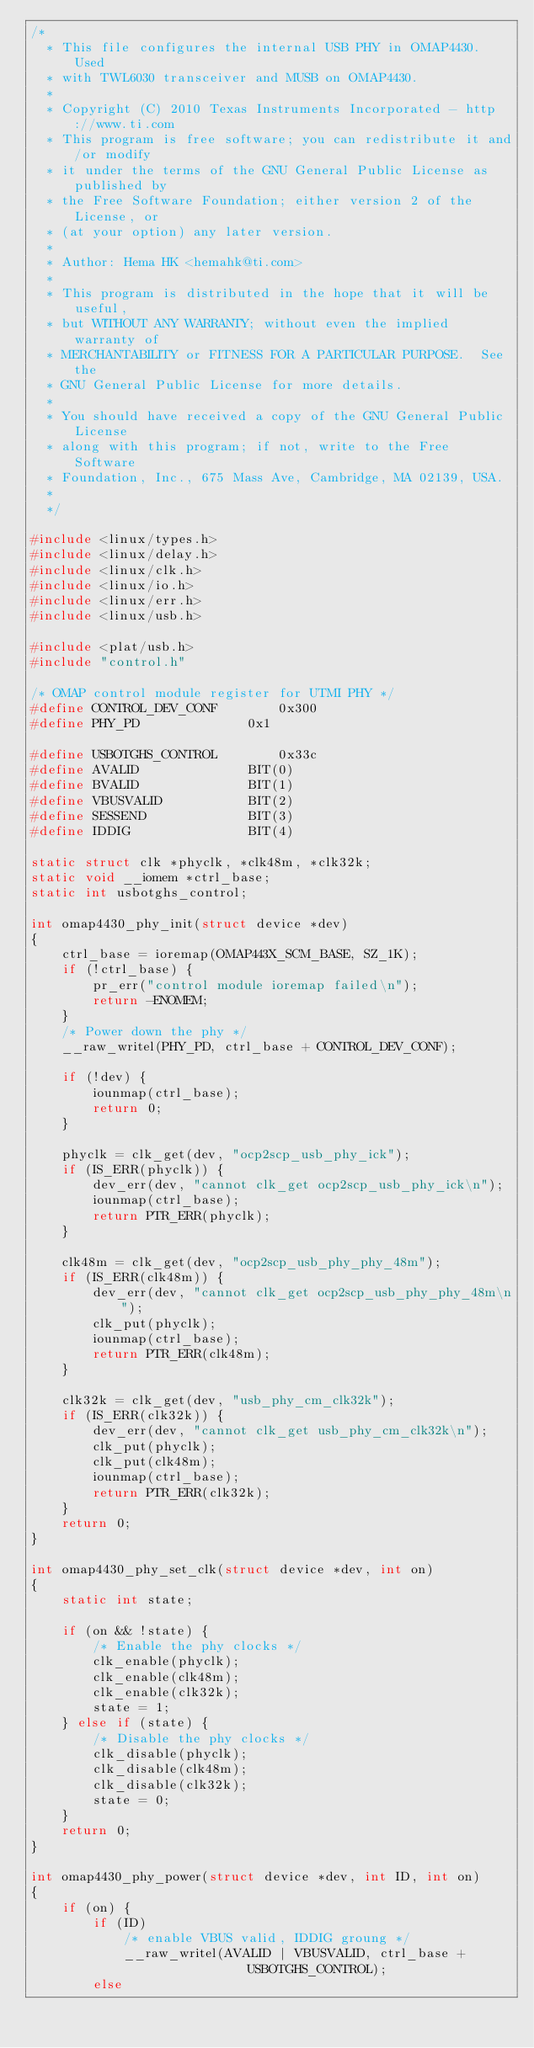<code> <loc_0><loc_0><loc_500><loc_500><_C_>/*
  * This file configures the internal USB PHY in OMAP4430. Used
  * with TWL6030 transceiver and MUSB on OMAP4430.
  *
  * Copyright (C) 2010 Texas Instruments Incorporated - http://www.ti.com
  * This program is free software; you can redistribute it and/or modify
  * it under the terms of the GNU General Public License as published by
  * the Free Software Foundation; either version 2 of the License, or
  * (at your option) any later version.
  *
  * Author: Hema HK <hemahk@ti.com>
  *
  * This program is distributed in the hope that it will be useful,
  * but WITHOUT ANY WARRANTY; without even the implied warranty of
  * MERCHANTABILITY or FITNESS FOR A PARTICULAR PURPOSE.  See the
  * GNU General Public License for more details.
  *
  * You should have received a copy of the GNU General Public License
  * along with this program; if not, write to the Free Software
  * Foundation, Inc., 675 Mass Ave, Cambridge, MA 02139, USA.
  *
  */

#include <linux/types.h>
#include <linux/delay.h>
#include <linux/clk.h>
#include <linux/io.h>
#include <linux/err.h>
#include <linux/usb.h>

#include <plat/usb.h>
#include "control.h"

/* OMAP control module register for UTMI PHY */
#define CONTROL_DEV_CONF		0x300
#define PHY_PD				0x1

#define USBOTGHS_CONTROL		0x33c
#define	AVALID				BIT(0)
#define	BVALID				BIT(1)
#define	VBUSVALID			BIT(2)
#define	SESSEND				BIT(3)
#define	IDDIG				BIT(4)

static struct clk *phyclk, *clk48m, *clk32k;
static void __iomem *ctrl_base;
static int usbotghs_control;

int omap4430_phy_init(struct device *dev)
{
	ctrl_base = ioremap(OMAP443X_SCM_BASE, SZ_1K);
	if (!ctrl_base) {
		pr_err("control module ioremap failed\n");
		return -ENOMEM;
	}
	/* Power down the phy */
	__raw_writel(PHY_PD, ctrl_base + CONTROL_DEV_CONF);

	if (!dev) {
		iounmap(ctrl_base);
		return 0;
	}

	phyclk = clk_get(dev, "ocp2scp_usb_phy_ick");
	if (IS_ERR(phyclk)) {
		dev_err(dev, "cannot clk_get ocp2scp_usb_phy_ick\n");
		iounmap(ctrl_base);
		return PTR_ERR(phyclk);
	}

	clk48m = clk_get(dev, "ocp2scp_usb_phy_phy_48m");
	if (IS_ERR(clk48m)) {
		dev_err(dev, "cannot clk_get ocp2scp_usb_phy_phy_48m\n");
		clk_put(phyclk);
		iounmap(ctrl_base);
		return PTR_ERR(clk48m);
	}

	clk32k = clk_get(dev, "usb_phy_cm_clk32k");
	if (IS_ERR(clk32k)) {
		dev_err(dev, "cannot clk_get usb_phy_cm_clk32k\n");
		clk_put(phyclk);
		clk_put(clk48m);
		iounmap(ctrl_base);
		return PTR_ERR(clk32k);
	}
	return 0;
}

int omap4430_phy_set_clk(struct device *dev, int on)
{
	static int state;

	if (on && !state) {
		/* Enable the phy clocks */
		clk_enable(phyclk);
		clk_enable(clk48m);
		clk_enable(clk32k);
		state = 1;
	} else if (state) {
		/* Disable the phy clocks */
		clk_disable(phyclk);
		clk_disable(clk48m);
		clk_disable(clk32k);
		state = 0;
	}
	return 0;
}

int omap4430_phy_power(struct device *dev, int ID, int on)
{
	if (on) {
		if (ID)
			/* enable VBUS valid, IDDIG groung */
			__raw_writel(AVALID | VBUSVALID, ctrl_base +
							USBOTGHS_CONTROL);
		else</code> 